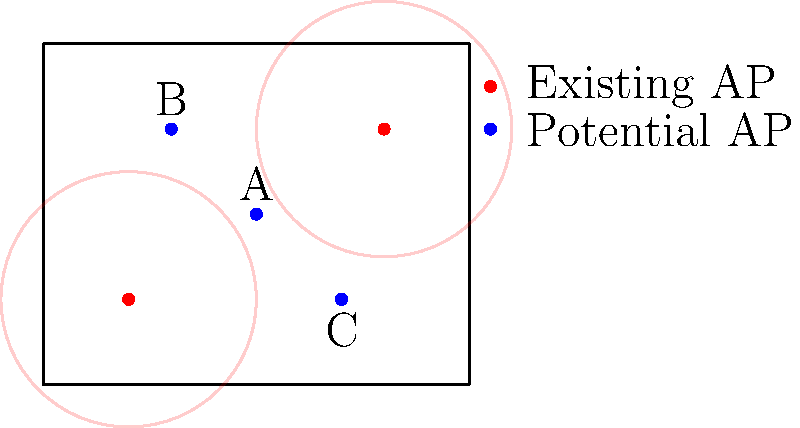Given the office layout with existing wireless access points (APs) shown in red and potential new AP locations shown in blue, which new AP location would provide the best coverage while minimizing interference with existing APs? To determine the best location for a new access point, we need to consider both coverage and interference:

1. Existing coverage:
   - Two APs are already installed at (2,2) and (8,6)
   - Their coverage areas are represented by red circles

2. Potential new AP locations:
   - A: (5,4)
   - B: (3,6)
   - C: (7,2)

3. Coverage analysis:
   - Location A (5,4) is centrally positioned, potentially covering areas not reached by existing APs
   - Location B (3,6) is close to the existing AP at (2,2), resulting in significant overlap
   - Location C (7,2) is close to the existing AP at (8,6), also resulting in overlap

4. Interference consideration:
   - Location A maintains the greatest distance from both existing APs, minimizing interference
   - Locations B and C are closer to existing APs, increasing the likelihood of interference

5. Optimal placement:
   - Location A provides the best balance of new coverage area and minimal interference
   - It fills the gap between existing APs and maintains sufficient distance to reduce signal conflicts

Therefore, the optimal choice for the new AP placement is location A (5,4).
Answer: A (5,4) 